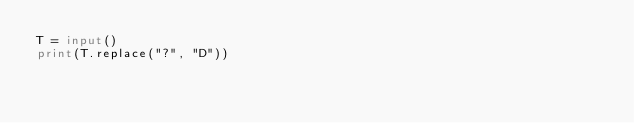<code> <loc_0><loc_0><loc_500><loc_500><_Python_>T = input()
print(T.replace("?", "D"))</code> 